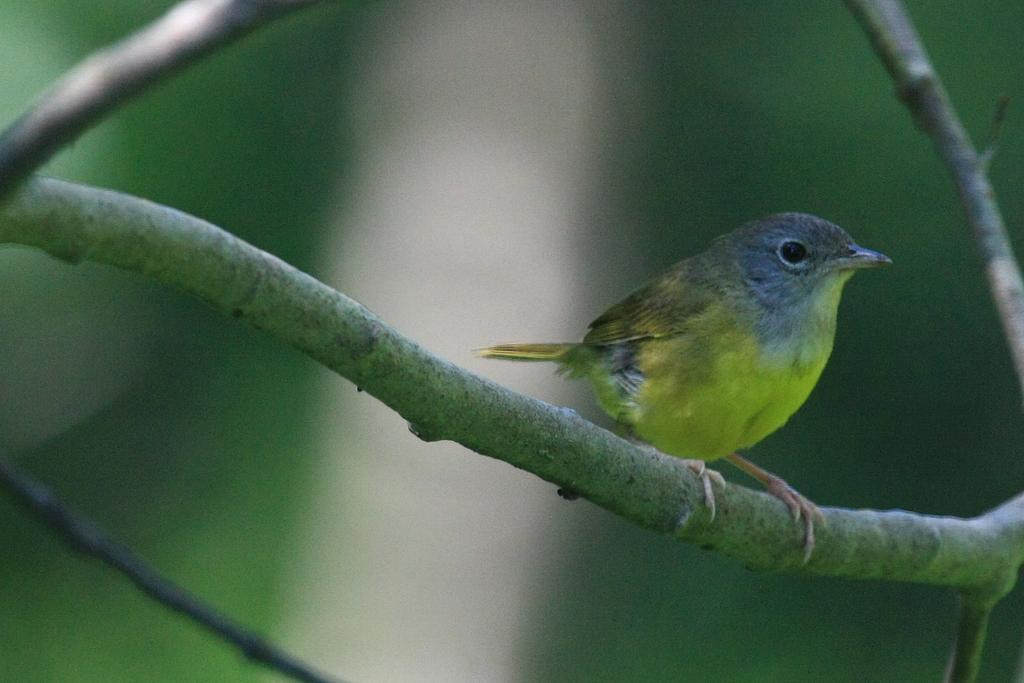What type of animal is in the image? There is a bird in the image. Where is the bird located? The bird is on a branch. What colors can be seen on the bird? The bird has green, black, and brown colors. Can you describe the background of the image? The background of the image is blurred. What type of pig can be seen in the image? There is no pig present in the image; it features a bird on a branch. What is the zephyr's role in the image? There is no zephyr mentioned or depicted in the image. 